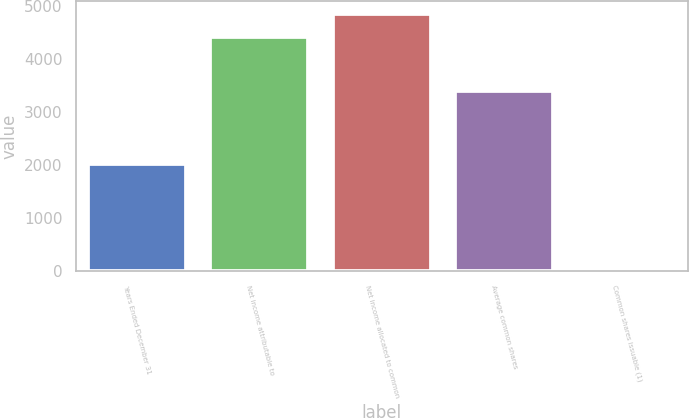Convert chart to OTSL. <chart><loc_0><loc_0><loc_500><loc_500><bar_chart><fcel>Years Ended December 31<fcel>Net income attributable to<fcel>Net income allocated to common<fcel>Average common shares<fcel>Common shares issuable (1)<nl><fcel>2013<fcel>4404<fcel>4841.1<fcel>3400.1<fcel>33<nl></chart> 